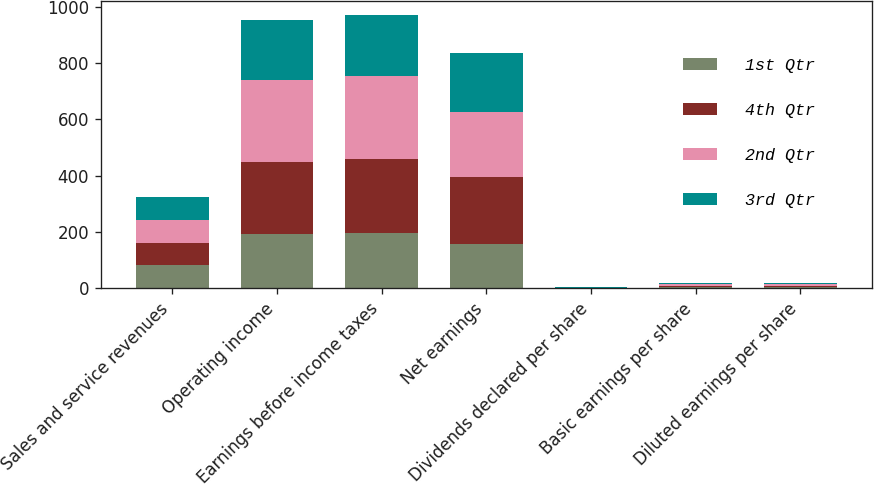Convert chart to OTSL. <chart><loc_0><loc_0><loc_500><loc_500><stacked_bar_chart><ecel><fcel>Sales and service revenues<fcel>Operating income<fcel>Earnings before income taxes<fcel>Net earnings<fcel>Dividends declared per share<fcel>Basic earnings per share<fcel>Diluted earnings per share<nl><fcel>1st Qtr<fcel>80.705<fcel>191<fcel>195<fcel>156<fcel>0.72<fcel>3.48<fcel>3.48<nl><fcel>4th Qtr<fcel>80.705<fcel>257<fcel>262<fcel>239<fcel>0.72<fcel>5.41<fcel>5.4<nl><fcel>2nd Qtr<fcel>80.705<fcel>290<fcel>295<fcel>229<fcel>0.72<fcel>5.29<fcel>5.29<nl><fcel>3rd Qtr<fcel>80.705<fcel>213<fcel>219<fcel>212<fcel>0.86<fcel>4.96<fcel>4.94<nl></chart> 